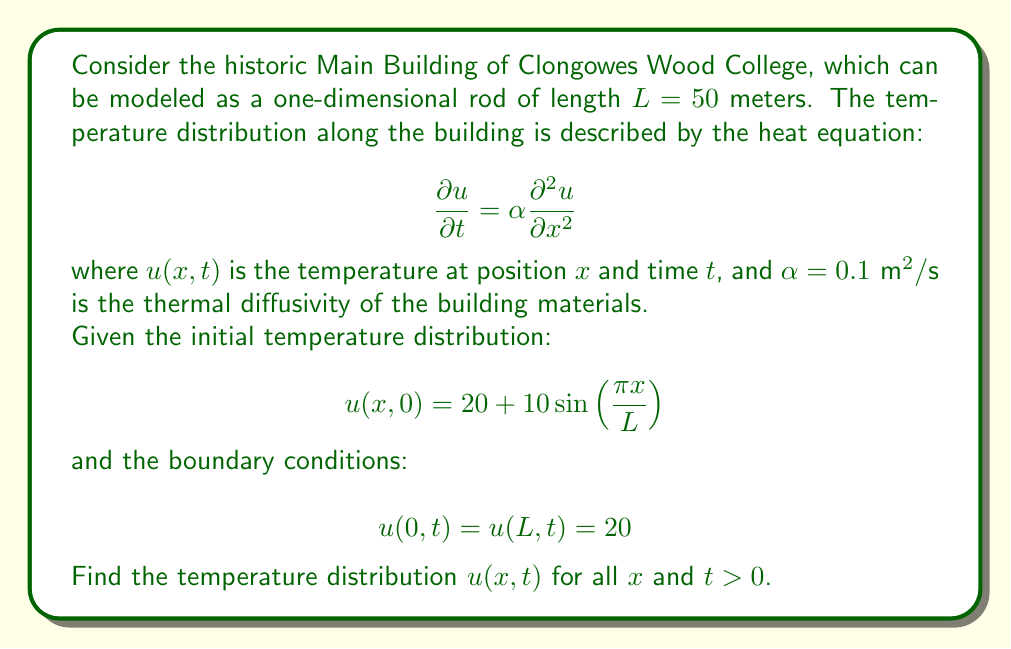What is the answer to this math problem? To solve this heat equation problem, we'll follow these steps:

1) The general solution to the heat equation with the given boundary conditions is of the form:

   $$u(x,t) = 20 + \sum_{n=1}^{\infty} b_n \sin\left(\frac{n\pi x}{L}\right) e^{-\alpha(n\pi/L)^2t}$$

2) We need to find the coefficients $b_n$ using the initial condition:

   $$20 + 10 \sin\left(\frac{\pi x}{L}\right) = 20 + \sum_{n=1}^{\infty} b_n \sin\left(\frac{n\pi x}{L}\right)$$

3) Comparing the terms, we can see that:
   
   $b_1 = 10$ and $b_n = 0$ for all $n > 1$

4) Therefore, our solution simplifies to:

   $$u(x,t) = 20 + 10 \sin\left(\frac{\pi x}{L}\right) e^{-\alpha(\pi/L)^2t}$$

5) Substituting the given values:

   $$u(x,t) = 20 + 10 \sin\left(\frac{\pi x}{50}\right) e^{-0.1(\pi/50)^2t}$$

This equation describes the temperature distribution in the Main Building of Clongowes Wood College at any position $x$ and time $t > 0$.
Answer: $$u(x,t) = 20 + 10 \sin\left(\frac{\pi x}{50}\right) e^{-0.1(\pi/50)^2t}$$ 